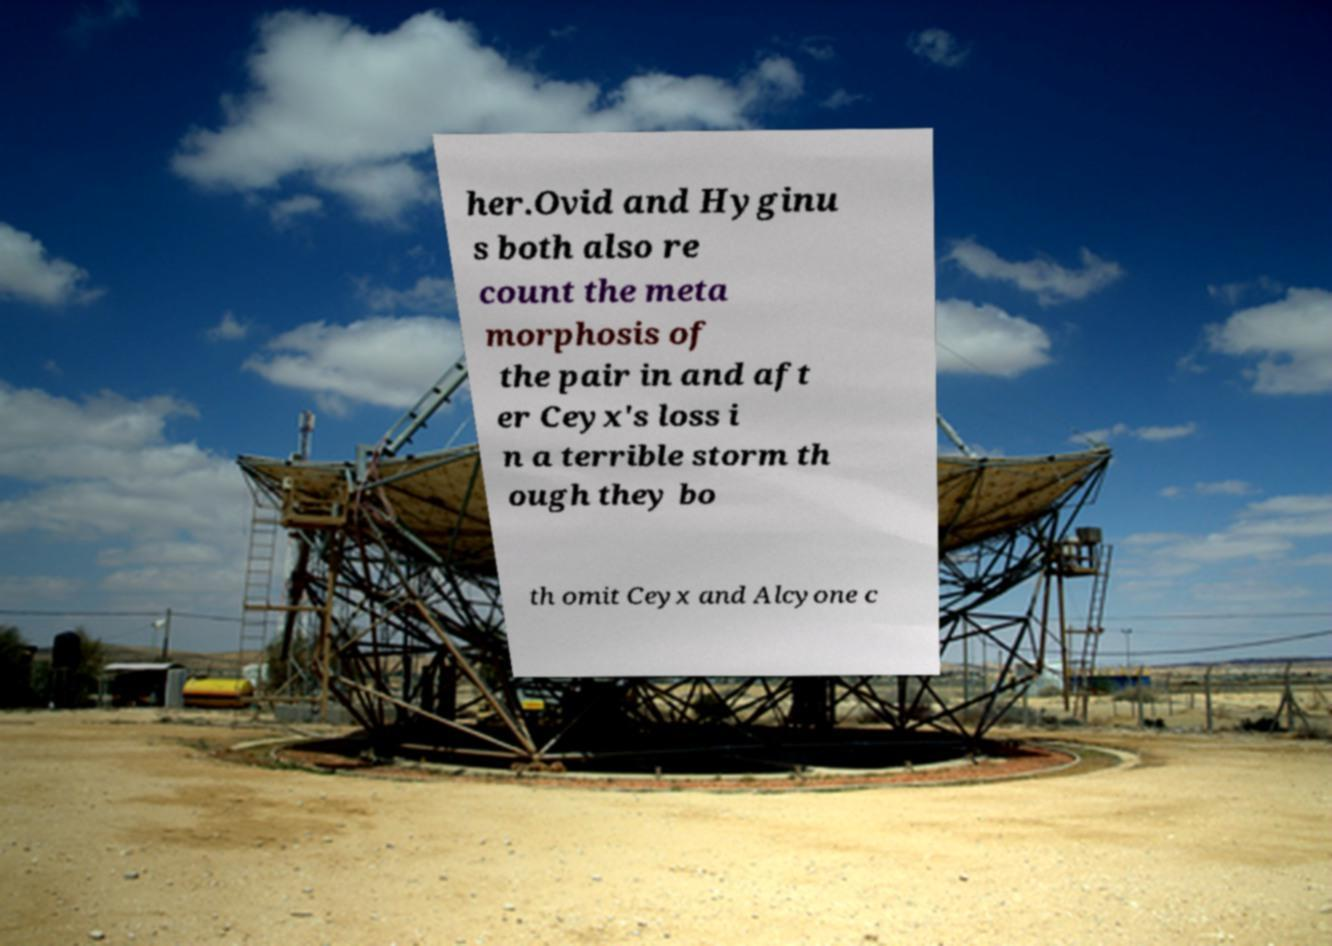Please identify and transcribe the text found in this image. her.Ovid and Hyginu s both also re count the meta morphosis of the pair in and aft er Ceyx's loss i n a terrible storm th ough they bo th omit Ceyx and Alcyone c 